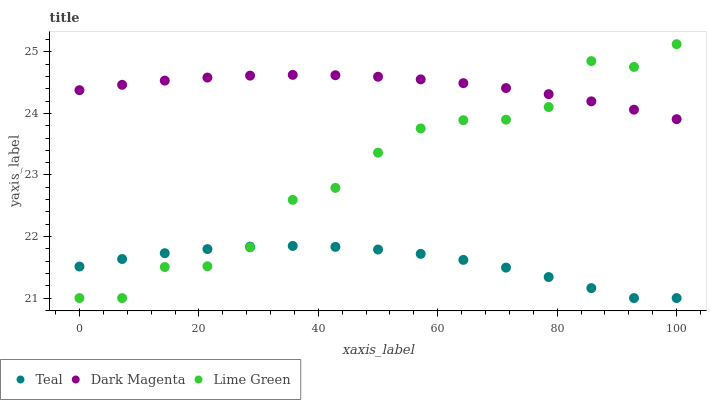Does Teal have the minimum area under the curve?
Answer yes or no. Yes. Does Dark Magenta have the maximum area under the curve?
Answer yes or no. Yes. Does Dark Magenta have the minimum area under the curve?
Answer yes or no. No. Does Teal have the maximum area under the curve?
Answer yes or no. No. Is Dark Magenta the smoothest?
Answer yes or no. Yes. Is Lime Green the roughest?
Answer yes or no. Yes. Is Teal the smoothest?
Answer yes or no. No. Is Teal the roughest?
Answer yes or no. No. Does Lime Green have the lowest value?
Answer yes or no. Yes. Does Dark Magenta have the lowest value?
Answer yes or no. No. Does Lime Green have the highest value?
Answer yes or no. Yes. Does Dark Magenta have the highest value?
Answer yes or no. No. Is Teal less than Dark Magenta?
Answer yes or no. Yes. Is Dark Magenta greater than Teal?
Answer yes or no. Yes. Does Teal intersect Lime Green?
Answer yes or no. Yes. Is Teal less than Lime Green?
Answer yes or no. No. Is Teal greater than Lime Green?
Answer yes or no. No. Does Teal intersect Dark Magenta?
Answer yes or no. No. 